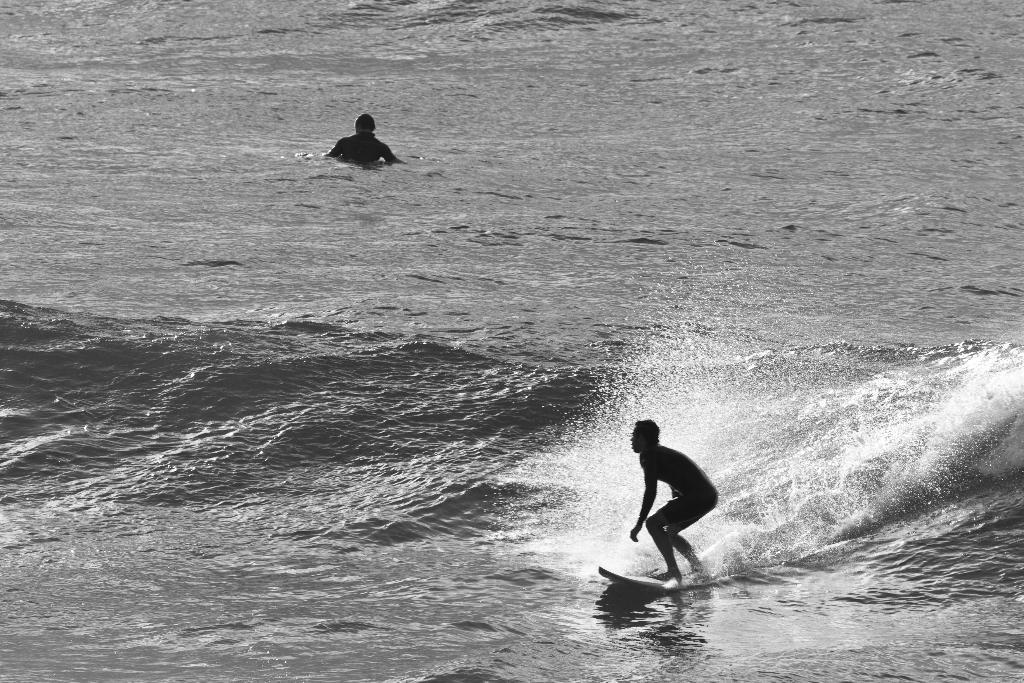Who is the main subject in the image? There is a person in the image. What activity is the person engaged in? The person is surfing. What tool is the person using for surfing? The person is using a surfboard. Where is the person located in the image? The person is on the water. What type of trousers is the person wearing while surfing in the image? The image does not show the person's trousers, so it cannot be determined from the image. 